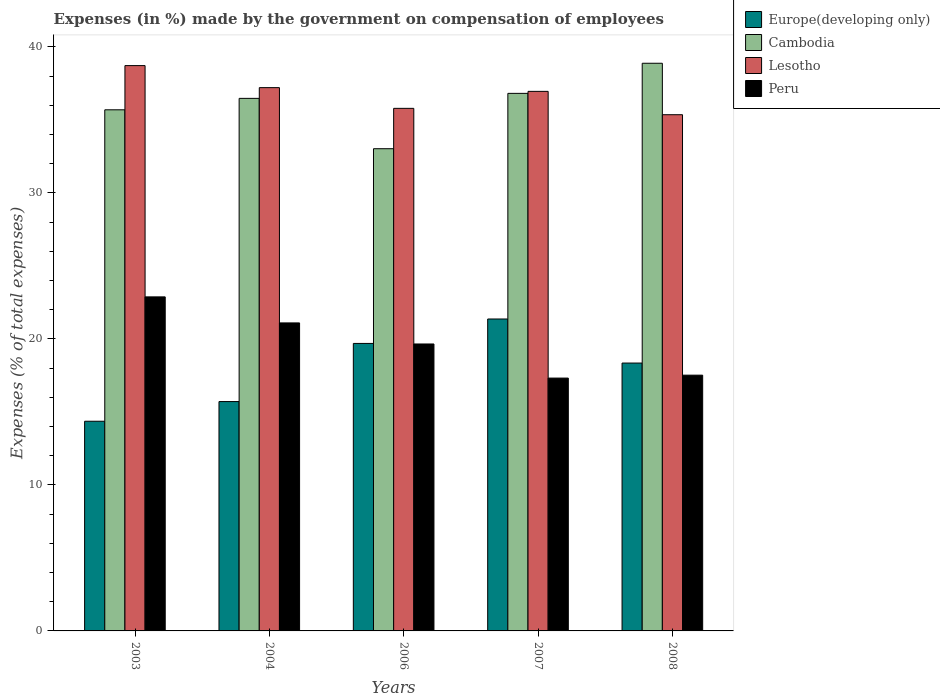How many different coloured bars are there?
Ensure brevity in your answer.  4. Are the number of bars on each tick of the X-axis equal?
Provide a short and direct response. Yes. What is the percentage of expenses made by the government on compensation of employees in Cambodia in 2003?
Make the answer very short. 35.7. Across all years, what is the maximum percentage of expenses made by the government on compensation of employees in Cambodia?
Your answer should be compact. 38.88. Across all years, what is the minimum percentage of expenses made by the government on compensation of employees in Peru?
Give a very brief answer. 17.32. In which year was the percentage of expenses made by the government on compensation of employees in Peru minimum?
Ensure brevity in your answer.  2007. What is the total percentage of expenses made by the government on compensation of employees in Peru in the graph?
Ensure brevity in your answer.  98.47. What is the difference between the percentage of expenses made by the government on compensation of employees in Cambodia in 2004 and that in 2008?
Your answer should be compact. -2.41. What is the difference between the percentage of expenses made by the government on compensation of employees in Europe(developing only) in 2007 and the percentage of expenses made by the government on compensation of employees in Peru in 2003?
Offer a very short reply. -1.52. What is the average percentage of expenses made by the government on compensation of employees in Cambodia per year?
Ensure brevity in your answer.  36.18. In the year 2007, what is the difference between the percentage of expenses made by the government on compensation of employees in Peru and percentage of expenses made by the government on compensation of employees in Cambodia?
Ensure brevity in your answer.  -19.5. What is the ratio of the percentage of expenses made by the government on compensation of employees in Cambodia in 2003 to that in 2007?
Provide a succinct answer. 0.97. Is the percentage of expenses made by the government on compensation of employees in Cambodia in 2003 less than that in 2008?
Your response must be concise. Yes. What is the difference between the highest and the second highest percentage of expenses made by the government on compensation of employees in Lesotho?
Your answer should be compact. 1.51. What is the difference between the highest and the lowest percentage of expenses made by the government on compensation of employees in Lesotho?
Make the answer very short. 3.36. In how many years, is the percentage of expenses made by the government on compensation of employees in Europe(developing only) greater than the average percentage of expenses made by the government on compensation of employees in Europe(developing only) taken over all years?
Provide a short and direct response. 3. Is the sum of the percentage of expenses made by the government on compensation of employees in Peru in 2003 and 2004 greater than the maximum percentage of expenses made by the government on compensation of employees in Europe(developing only) across all years?
Your response must be concise. Yes. What does the 2nd bar from the left in 2008 represents?
Provide a short and direct response. Cambodia. What does the 4th bar from the right in 2006 represents?
Your response must be concise. Europe(developing only). Is it the case that in every year, the sum of the percentage of expenses made by the government on compensation of employees in Europe(developing only) and percentage of expenses made by the government on compensation of employees in Peru is greater than the percentage of expenses made by the government on compensation of employees in Cambodia?
Your response must be concise. No. How many bars are there?
Your answer should be very brief. 20. Does the graph contain any zero values?
Your response must be concise. No. Does the graph contain grids?
Keep it short and to the point. No. Where does the legend appear in the graph?
Give a very brief answer. Top right. What is the title of the graph?
Offer a very short reply. Expenses (in %) made by the government on compensation of employees. What is the label or title of the X-axis?
Your answer should be compact. Years. What is the label or title of the Y-axis?
Offer a terse response. Expenses (% of total expenses). What is the Expenses (% of total expenses) of Europe(developing only) in 2003?
Offer a very short reply. 14.36. What is the Expenses (% of total expenses) in Cambodia in 2003?
Offer a terse response. 35.7. What is the Expenses (% of total expenses) of Lesotho in 2003?
Give a very brief answer. 38.72. What is the Expenses (% of total expenses) of Peru in 2003?
Offer a very short reply. 22.88. What is the Expenses (% of total expenses) of Europe(developing only) in 2004?
Your answer should be very brief. 15.71. What is the Expenses (% of total expenses) in Cambodia in 2004?
Provide a succinct answer. 36.48. What is the Expenses (% of total expenses) in Lesotho in 2004?
Offer a terse response. 37.21. What is the Expenses (% of total expenses) of Peru in 2004?
Your answer should be compact. 21.1. What is the Expenses (% of total expenses) in Europe(developing only) in 2006?
Your answer should be very brief. 19.69. What is the Expenses (% of total expenses) of Cambodia in 2006?
Provide a succinct answer. 33.03. What is the Expenses (% of total expenses) in Lesotho in 2006?
Your answer should be very brief. 35.8. What is the Expenses (% of total expenses) of Peru in 2006?
Keep it short and to the point. 19.65. What is the Expenses (% of total expenses) of Europe(developing only) in 2007?
Offer a terse response. 21.37. What is the Expenses (% of total expenses) in Cambodia in 2007?
Provide a succinct answer. 36.82. What is the Expenses (% of total expenses) of Lesotho in 2007?
Provide a short and direct response. 36.96. What is the Expenses (% of total expenses) in Peru in 2007?
Make the answer very short. 17.32. What is the Expenses (% of total expenses) of Europe(developing only) in 2008?
Ensure brevity in your answer.  18.35. What is the Expenses (% of total expenses) of Cambodia in 2008?
Your answer should be very brief. 38.88. What is the Expenses (% of total expenses) in Lesotho in 2008?
Your answer should be very brief. 35.36. What is the Expenses (% of total expenses) in Peru in 2008?
Make the answer very short. 17.52. Across all years, what is the maximum Expenses (% of total expenses) in Europe(developing only)?
Your response must be concise. 21.37. Across all years, what is the maximum Expenses (% of total expenses) in Cambodia?
Provide a short and direct response. 38.88. Across all years, what is the maximum Expenses (% of total expenses) in Lesotho?
Your response must be concise. 38.72. Across all years, what is the maximum Expenses (% of total expenses) in Peru?
Provide a short and direct response. 22.88. Across all years, what is the minimum Expenses (% of total expenses) in Europe(developing only)?
Your answer should be very brief. 14.36. Across all years, what is the minimum Expenses (% of total expenses) of Cambodia?
Keep it short and to the point. 33.03. Across all years, what is the minimum Expenses (% of total expenses) of Lesotho?
Offer a terse response. 35.36. Across all years, what is the minimum Expenses (% of total expenses) of Peru?
Make the answer very short. 17.32. What is the total Expenses (% of total expenses) of Europe(developing only) in the graph?
Make the answer very short. 89.48. What is the total Expenses (% of total expenses) of Cambodia in the graph?
Your answer should be very brief. 180.91. What is the total Expenses (% of total expenses) in Lesotho in the graph?
Give a very brief answer. 184.05. What is the total Expenses (% of total expenses) in Peru in the graph?
Give a very brief answer. 98.47. What is the difference between the Expenses (% of total expenses) of Europe(developing only) in 2003 and that in 2004?
Offer a very short reply. -1.35. What is the difference between the Expenses (% of total expenses) of Cambodia in 2003 and that in 2004?
Your answer should be compact. -0.78. What is the difference between the Expenses (% of total expenses) in Lesotho in 2003 and that in 2004?
Ensure brevity in your answer.  1.51. What is the difference between the Expenses (% of total expenses) in Peru in 2003 and that in 2004?
Make the answer very short. 1.78. What is the difference between the Expenses (% of total expenses) of Europe(developing only) in 2003 and that in 2006?
Ensure brevity in your answer.  -5.33. What is the difference between the Expenses (% of total expenses) of Cambodia in 2003 and that in 2006?
Make the answer very short. 2.67. What is the difference between the Expenses (% of total expenses) in Lesotho in 2003 and that in 2006?
Your response must be concise. 2.93. What is the difference between the Expenses (% of total expenses) in Peru in 2003 and that in 2006?
Ensure brevity in your answer.  3.23. What is the difference between the Expenses (% of total expenses) of Europe(developing only) in 2003 and that in 2007?
Give a very brief answer. -7. What is the difference between the Expenses (% of total expenses) of Cambodia in 2003 and that in 2007?
Your response must be concise. -1.13. What is the difference between the Expenses (% of total expenses) in Lesotho in 2003 and that in 2007?
Give a very brief answer. 1.76. What is the difference between the Expenses (% of total expenses) of Peru in 2003 and that in 2007?
Your answer should be very brief. 5.56. What is the difference between the Expenses (% of total expenses) of Europe(developing only) in 2003 and that in 2008?
Ensure brevity in your answer.  -3.99. What is the difference between the Expenses (% of total expenses) in Cambodia in 2003 and that in 2008?
Offer a very short reply. -3.19. What is the difference between the Expenses (% of total expenses) in Lesotho in 2003 and that in 2008?
Make the answer very short. 3.36. What is the difference between the Expenses (% of total expenses) of Peru in 2003 and that in 2008?
Make the answer very short. 5.36. What is the difference between the Expenses (% of total expenses) in Europe(developing only) in 2004 and that in 2006?
Offer a terse response. -3.98. What is the difference between the Expenses (% of total expenses) of Cambodia in 2004 and that in 2006?
Your answer should be compact. 3.45. What is the difference between the Expenses (% of total expenses) in Lesotho in 2004 and that in 2006?
Provide a short and direct response. 1.42. What is the difference between the Expenses (% of total expenses) in Peru in 2004 and that in 2006?
Ensure brevity in your answer.  1.44. What is the difference between the Expenses (% of total expenses) in Europe(developing only) in 2004 and that in 2007?
Make the answer very short. -5.66. What is the difference between the Expenses (% of total expenses) of Cambodia in 2004 and that in 2007?
Provide a short and direct response. -0.34. What is the difference between the Expenses (% of total expenses) in Lesotho in 2004 and that in 2007?
Ensure brevity in your answer.  0.26. What is the difference between the Expenses (% of total expenses) of Peru in 2004 and that in 2007?
Offer a very short reply. 3.78. What is the difference between the Expenses (% of total expenses) in Europe(developing only) in 2004 and that in 2008?
Offer a very short reply. -2.64. What is the difference between the Expenses (% of total expenses) in Cambodia in 2004 and that in 2008?
Provide a short and direct response. -2.41. What is the difference between the Expenses (% of total expenses) of Lesotho in 2004 and that in 2008?
Provide a short and direct response. 1.85. What is the difference between the Expenses (% of total expenses) of Peru in 2004 and that in 2008?
Your answer should be very brief. 3.58. What is the difference between the Expenses (% of total expenses) in Europe(developing only) in 2006 and that in 2007?
Your answer should be very brief. -1.67. What is the difference between the Expenses (% of total expenses) of Cambodia in 2006 and that in 2007?
Provide a short and direct response. -3.79. What is the difference between the Expenses (% of total expenses) in Lesotho in 2006 and that in 2007?
Give a very brief answer. -1.16. What is the difference between the Expenses (% of total expenses) in Peru in 2006 and that in 2007?
Offer a terse response. 2.34. What is the difference between the Expenses (% of total expenses) of Europe(developing only) in 2006 and that in 2008?
Your answer should be very brief. 1.34. What is the difference between the Expenses (% of total expenses) in Cambodia in 2006 and that in 2008?
Your response must be concise. -5.85. What is the difference between the Expenses (% of total expenses) of Lesotho in 2006 and that in 2008?
Give a very brief answer. 0.44. What is the difference between the Expenses (% of total expenses) of Peru in 2006 and that in 2008?
Provide a short and direct response. 2.14. What is the difference between the Expenses (% of total expenses) of Europe(developing only) in 2007 and that in 2008?
Keep it short and to the point. 3.02. What is the difference between the Expenses (% of total expenses) in Cambodia in 2007 and that in 2008?
Offer a terse response. -2.06. What is the difference between the Expenses (% of total expenses) of Lesotho in 2007 and that in 2008?
Offer a very short reply. 1.6. What is the difference between the Expenses (% of total expenses) of Europe(developing only) in 2003 and the Expenses (% of total expenses) of Cambodia in 2004?
Your answer should be compact. -22.12. What is the difference between the Expenses (% of total expenses) in Europe(developing only) in 2003 and the Expenses (% of total expenses) in Lesotho in 2004?
Offer a terse response. -22.85. What is the difference between the Expenses (% of total expenses) in Europe(developing only) in 2003 and the Expenses (% of total expenses) in Peru in 2004?
Give a very brief answer. -6.74. What is the difference between the Expenses (% of total expenses) of Cambodia in 2003 and the Expenses (% of total expenses) of Lesotho in 2004?
Your answer should be compact. -1.52. What is the difference between the Expenses (% of total expenses) in Cambodia in 2003 and the Expenses (% of total expenses) in Peru in 2004?
Keep it short and to the point. 14.6. What is the difference between the Expenses (% of total expenses) of Lesotho in 2003 and the Expenses (% of total expenses) of Peru in 2004?
Provide a short and direct response. 17.63. What is the difference between the Expenses (% of total expenses) in Europe(developing only) in 2003 and the Expenses (% of total expenses) in Cambodia in 2006?
Keep it short and to the point. -18.67. What is the difference between the Expenses (% of total expenses) of Europe(developing only) in 2003 and the Expenses (% of total expenses) of Lesotho in 2006?
Provide a succinct answer. -21.43. What is the difference between the Expenses (% of total expenses) in Europe(developing only) in 2003 and the Expenses (% of total expenses) in Peru in 2006?
Provide a short and direct response. -5.29. What is the difference between the Expenses (% of total expenses) of Cambodia in 2003 and the Expenses (% of total expenses) of Lesotho in 2006?
Keep it short and to the point. -0.1. What is the difference between the Expenses (% of total expenses) in Cambodia in 2003 and the Expenses (% of total expenses) in Peru in 2006?
Offer a terse response. 16.04. What is the difference between the Expenses (% of total expenses) in Lesotho in 2003 and the Expenses (% of total expenses) in Peru in 2006?
Keep it short and to the point. 19.07. What is the difference between the Expenses (% of total expenses) in Europe(developing only) in 2003 and the Expenses (% of total expenses) in Cambodia in 2007?
Offer a very short reply. -22.46. What is the difference between the Expenses (% of total expenses) in Europe(developing only) in 2003 and the Expenses (% of total expenses) in Lesotho in 2007?
Your answer should be compact. -22.6. What is the difference between the Expenses (% of total expenses) of Europe(developing only) in 2003 and the Expenses (% of total expenses) of Peru in 2007?
Offer a very short reply. -2.96. What is the difference between the Expenses (% of total expenses) in Cambodia in 2003 and the Expenses (% of total expenses) in Lesotho in 2007?
Keep it short and to the point. -1.26. What is the difference between the Expenses (% of total expenses) of Cambodia in 2003 and the Expenses (% of total expenses) of Peru in 2007?
Your answer should be very brief. 18.38. What is the difference between the Expenses (% of total expenses) of Lesotho in 2003 and the Expenses (% of total expenses) of Peru in 2007?
Make the answer very short. 21.4. What is the difference between the Expenses (% of total expenses) of Europe(developing only) in 2003 and the Expenses (% of total expenses) of Cambodia in 2008?
Your response must be concise. -24.52. What is the difference between the Expenses (% of total expenses) in Europe(developing only) in 2003 and the Expenses (% of total expenses) in Lesotho in 2008?
Offer a very short reply. -21. What is the difference between the Expenses (% of total expenses) of Europe(developing only) in 2003 and the Expenses (% of total expenses) of Peru in 2008?
Ensure brevity in your answer.  -3.16. What is the difference between the Expenses (% of total expenses) of Cambodia in 2003 and the Expenses (% of total expenses) of Lesotho in 2008?
Offer a terse response. 0.34. What is the difference between the Expenses (% of total expenses) in Cambodia in 2003 and the Expenses (% of total expenses) in Peru in 2008?
Make the answer very short. 18.18. What is the difference between the Expenses (% of total expenses) of Lesotho in 2003 and the Expenses (% of total expenses) of Peru in 2008?
Give a very brief answer. 21.2. What is the difference between the Expenses (% of total expenses) of Europe(developing only) in 2004 and the Expenses (% of total expenses) of Cambodia in 2006?
Ensure brevity in your answer.  -17.32. What is the difference between the Expenses (% of total expenses) of Europe(developing only) in 2004 and the Expenses (% of total expenses) of Lesotho in 2006?
Your answer should be compact. -20.09. What is the difference between the Expenses (% of total expenses) of Europe(developing only) in 2004 and the Expenses (% of total expenses) of Peru in 2006?
Provide a succinct answer. -3.95. What is the difference between the Expenses (% of total expenses) in Cambodia in 2004 and the Expenses (% of total expenses) in Lesotho in 2006?
Keep it short and to the point. 0.68. What is the difference between the Expenses (% of total expenses) in Cambodia in 2004 and the Expenses (% of total expenses) in Peru in 2006?
Provide a succinct answer. 16.82. What is the difference between the Expenses (% of total expenses) in Lesotho in 2004 and the Expenses (% of total expenses) in Peru in 2006?
Give a very brief answer. 17.56. What is the difference between the Expenses (% of total expenses) in Europe(developing only) in 2004 and the Expenses (% of total expenses) in Cambodia in 2007?
Your answer should be very brief. -21.11. What is the difference between the Expenses (% of total expenses) in Europe(developing only) in 2004 and the Expenses (% of total expenses) in Lesotho in 2007?
Offer a terse response. -21.25. What is the difference between the Expenses (% of total expenses) in Europe(developing only) in 2004 and the Expenses (% of total expenses) in Peru in 2007?
Ensure brevity in your answer.  -1.61. What is the difference between the Expenses (% of total expenses) of Cambodia in 2004 and the Expenses (% of total expenses) of Lesotho in 2007?
Your answer should be very brief. -0.48. What is the difference between the Expenses (% of total expenses) of Cambodia in 2004 and the Expenses (% of total expenses) of Peru in 2007?
Provide a short and direct response. 19.16. What is the difference between the Expenses (% of total expenses) of Lesotho in 2004 and the Expenses (% of total expenses) of Peru in 2007?
Provide a succinct answer. 19.89. What is the difference between the Expenses (% of total expenses) in Europe(developing only) in 2004 and the Expenses (% of total expenses) in Cambodia in 2008?
Provide a succinct answer. -23.17. What is the difference between the Expenses (% of total expenses) of Europe(developing only) in 2004 and the Expenses (% of total expenses) of Lesotho in 2008?
Provide a short and direct response. -19.65. What is the difference between the Expenses (% of total expenses) of Europe(developing only) in 2004 and the Expenses (% of total expenses) of Peru in 2008?
Your answer should be very brief. -1.81. What is the difference between the Expenses (% of total expenses) in Cambodia in 2004 and the Expenses (% of total expenses) in Lesotho in 2008?
Provide a succinct answer. 1.12. What is the difference between the Expenses (% of total expenses) of Cambodia in 2004 and the Expenses (% of total expenses) of Peru in 2008?
Provide a short and direct response. 18.96. What is the difference between the Expenses (% of total expenses) of Lesotho in 2004 and the Expenses (% of total expenses) of Peru in 2008?
Make the answer very short. 19.69. What is the difference between the Expenses (% of total expenses) of Europe(developing only) in 2006 and the Expenses (% of total expenses) of Cambodia in 2007?
Your answer should be very brief. -17.13. What is the difference between the Expenses (% of total expenses) of Europe(developing only) in 2006 and the Expenses (% of total expenses) of Lesotho in 2007?
Offer a very short reply. -17.27. What is the difference between the Expenses (% of total expenses) in Europe(developing only) in 2006 and the Expenses (% of total expenses) in Peru in 2007?
Offer a terse response. 2.37. What is the difference between the Expenses (% of total expenses) in Cambodia in 2006 and the Expenses (% of total expenses) in Lesotho in 2007?
Ensure brevity in your answer.  -3.93. What is the difference between the Expenses (% of total expenses) of Cambodia in 2006 and the Expenses (% of total expenses) of Peru in 2007?
Provide a short and direct response. 15.71. What is the difference between the Expenses (% of total expenses) in Lesotho in 2006 and the Expenses (% of total expenses) in Peru in 2007?
Give a very brief answer. 18.48. What is the difference between the Expenses (% of total expenses) of Europe(developing only) in 2006 and the Expenses (% of total expenses) of Cambodia in 2008?
Provide a succinct answer. -19.19. What is the difference between the Expenses (% of total expenses) of Europe(developing only) in 2006 and the Expenses (% of total expenses) of Lesotho in 2008?
Ensure brevity in your answer.  -15.67. What is the difference between the Expenses (% of total expenses) of Europe(developing only) in 2006 and the Expenses (% of total expenses) of Peru in 2008?
Provide a succinct answer. 2.17. What is the difference between the Expenses (% of total expenses) of Cambodia in 2006 and the Expenses (% of total expenses) of Lesotho in 2008?
Provide a short and direct response. -2.33. What is the difference between the Expenses (% of total expenses) in Cambodia in 2006 and the Expenses (% of total expenses) in Peru in 2008?
Ensure brevity in your answer.  15.51. What is the difference between the Expenses (% of total expenses) in Lesotho in 2006 and the Expenses (% of total expenses) in Peru in 2008?
Your response must be concise. 18.28. What is the difference between the Expenses (% of total expenses) in Europe(developing only) in 2007 and the Expenses (% of total expenses) in Cambodia in 2008?
Your answer should be compact. -17.52. What is the difference between the Expenses (% of total expenses) of Europe(developing only) in 2007 and the Expenses (% of total expenses) of Lesotho in 2008?
Keep it short and to the point. -13.99. What is the difference between the Expenses (% of total expenses) in Europe(developing only) in 2007 and the Expenses (% of total expenses) in Peru in 2008?
Ensure brevity in your answer.  3.85. What is the difference between the Expenses (% of total expenses) in Cambodia in 2007 and the Expenses (% of total expenses) in Lesotho in 2008?
Provide a short and direct response. 1.46. What is the difference between the Expenses (% of total expenses) of Cambodia in 2007 and the Expenses (% of total expenses) of Peru in 2008?
Give a very brief answer. 19.3. What is the difference between the Expenses (% of total expenses) of Lesotho in 2007 and the Expenses (% of total expenses) of Peru in 2008?
Your response must be concise. 19.44. What is the average Expenses (% of total expenses) in Europe(developing only) per year?
Make the answer very short. 17.9. What is the average Expenses (% of total expenses) of Cambodia per year?
Give a very brief answer. 36.18. What is the average Expenses (% of total expenses) in Lesotho per year?
Offer a terse response. 36.81. What is the average Expenses (% of total expenses) of Peru per year?
Provide a short and direct response. 19.69. In the year 2003, what is the difference between the Expenses (% of total expenses) in Europe(developing only) and Expenses (% of total expenses) in Cambodia?
Offer a terse response. -21.33. In the year 2003, what is the difference between the Expenses (% of total expenses) of Europe(developing only) and Expenses (% of total expenses) of Lesotho?
Your answer should be very brief. -24.36. In the year 2003, what is the difference between the Expenses (% of total expenses) of Europe(developing only) and Expenses (% of total expenses) of Peru?
Keep it short and to the point. -8.52. In the year 2003, what is the difference between the Expenses (% of total expenses) of Cambodia and Expenses (% of total expenses) of Lesotho?
Your answer should be compact. -3.03. In the year 2003, what is the difference between the Expenses (% of total expenses) in Cambodia and Expenses (% of total expenses) in Peru?
Make the answer very short. 12.81. In the year 2003, what is the difference between the Expenses (% of total expenses) in Lesotho and Expenses (% of total expenses) in Peru?
Offer a terse response. 15.84. In the year 2004, what is the difference between the Expenses (% of total expenses) in Europe(developing only) and Expenses (% of total expenses) in Cambodia?
Your answer should be compact. -20.77. In the year 2004, what is the difference between the Expenses (% of total expenses) of Europe(developing only) and Expenses (% of total expenses) of Lesotho?
Your answer should be very brief. -21.5. In the year 2004, what is the difference between the Expenses (% of total expenses) of Europe(developing only) and Expenses (% of total expenses) of Peru?
Your response must be concise. -5.39. In the year 2004, what is the difference between the Expenses (% of total expenses) of Cambodia and Expenses (% of total expenses) of Lesotho?
Offer a very short reply. -0.74. In the year 2004, what is the difference between the Expenses (% of total expenses) in Cambodia and Expenses (% of total expenses) in Peru?
Provide a short and direct response. 15.38. In the year 2004, what is the difference between the Expenses (% of total expenses) of Lesotho and Expenses (% of total expenses) of Peru?
Offer a very short reply. 16.12. In the year 2006, what is the difference between the Expenses (% of total expenses) in Europe(developing only) and Expenses (% of total expenses) in Cambodia?
Your answer should be compact. -13.34. In the year 2006, what is the difference between the Expenses (% of total expenses) in Europe(developing only) and Expenses (% of total expenses) in Lesotho?
Your answer should be compact. -16.1. In the year 2006, what is the difference between the Expenses (% of total expenses) in Europe(developing only) and Expenses (% of total expenses) in Peru?
Offer a very short reply. 0.04. In the year 2006, what is the difference between the Expenses (% of total expenses) in Cambodia and Expenses (% of total expenses) in Lesotho?
Offer a very short reply. -2.77. In the year 2006, what is the difference between the Expenses (% of total expenses) in Cambodia and Expenses (% of total expenses) in Peru?
Make the answer very short. 13.37. In the year 2006, what is the difference between the Expenses (% of total expenses) of Lesotho and Expenses (% of total expenses) of Peru?
Your answer should be very brief. 16.14. In the year 2007, what is the difference between the Expenses (% of total expenses) in Europe(developing only) and Expenses (% of total expenses) in Cambodia?
Offer a very short reply. -15.46. In the year 2007, what is the difference between the Expenses (% of total expenses) of Europe(developing only) and Expenses (% of total expenses) of Lesotho?
Provide a succinct answer. -15.59. In the year 2007, what is the difference between the Expenses (% of total expenses) of Europe(developing only) and Expenses (% of total expenses) of Peru?
Provide a short and direct response. 4.05. In the year 2007, what is the difference between the Expenses (% of total expenses) of Cambodia and Expenses (% of total expenses) of Lesotho?
Offer a very short reply. -0.14. In the year 2007, what is the difference between the Expenses (% of total expenses) in Cambodia and Expenses (% of total expenses) in Peru?
Keep it short and to the point. 19.5. In the year 2007, what is the difference between the Expenses (% of total expenses) in Lesotho and Expenses (% of total expenses) in Peru?
Offer a very short reply. 19.64. In the year 2008, what is the difference between the Expenses (% of total expenses) of Europe(developing only) and Expenses (% of total expenses) of Cambodia?
Make the answer very short. -20.54. In the year 2008, what is the difference between the Expenses (% of total expenses) in Europe(developing only) and Expenses (% of total expenses) in Lesotho?
Your response must be concise. -17.01. In the year 2008, what is the difference between the Expenses (% of total expenses) in Europe(developing only) and Expenses (% of total expenses) in Peru?
Give a very brief answer. 0.83. In the year 2008, what is the difference between the Expenses (% of total expenses) of Cambodia and Expenses (% of total expenses) of Lesotho?
Keep it short and to the point. 3.52. In the year 2008, what is the difference between the Expenses (% of total expenses) in Cambodia and Expenses (% of total expenses) in Peru?
Keep it short and to the point. 21.36. In the year 2008, what is the difference between the Expenses (% of total expenses) of Lesotho and Expenses (% of total expenses) of Peru?
Offer a very short reply. 17.84. What is the ratio of the Expenses (% of total expenses) of Europe(developing only) in 2003 to that in 2004?
Ensure brevity in your answer.  0.91. What is the ratio of the Expenses (% of total expenses) of Cambodia in 2003 to that in 2004?
Keep it short and to the point. 0.98. What is the ratio of the Expenses (% of total expenses) of Lesotho in 2003 to that in 2004?
Offer a very short reply. 1.04. What is the ratio of the Expenses (% of total expenses) of Peru in 2003 to that in 2004?
Your answer should be very brief. 1.08. What is the ratio of the Expenses (% of total expenses) in Europe(developing only) in 2003 to that in 2006?
Your response must be concise. 0.73. What is the ratio of the Expenses (% of total expenses) of Cambodia in 2003 to that in 2006?
Offer a very short reply. 1.08. What is the ratio of the Expenses (% of total expenses) of Lesotho in 2003 to that in 2006?
Provide a short and direct response. 1.08. What is the ratio of the Expenses (% of total expenses) of Peru in 2003 to that in 2006?
Offer a very short reply. 1.16. What is the ratio of the Expenses (% of total expenses) in Europe(developing only) in 2003 to that in 2007?
Ensure brevity in your answer.  0.67. What is the ratio of the Expenses (% of total expenses) in Cambodia in 2003 to that in 2007?
Offer a very short reply. 0.97. What is the ratio of the Expenses (% of total expenses) of Lesotho in 2003 to that in 2007?
Keep it short and to the point. 1.05. What is the ratio of the Expenses (% of total expenses) of Peru in 2003 to that in 2007?
Ensure brevity in your answer.  1.32. What is the ratio of the Expenses (% of total expenses) of Europe(developing only) in 2003 to that in 2008?
Ensure brevity in your answer.  0.78. What is the ratio of the Expenses (% of total expenses) in Cambodia in 2003 to that in 2008?
Make the answer very short. 0.92. What is the ratio of the Expenses (% of total expenses) in Lesotho in 2003 to that in 2008?
Your response must be concise. 1.1. What is the ratio of the Expenses (% of total expenses) of Peru in 2003 to that in 2008?
Make the answer very short. 1.31. What is the ratio of the Expenses (% of total expenses) of Europe(developing only) in 2004 to that in 2006?
Provide a short and direct response. 0.8. What is the ratio of the Expenses (% of total expenses) of Cambodia in 2004 to that in 2006?
Give a very brief answer. 1.1. What is the ratio of the Expenses (% of total expenses) in Lesotho in 2004 to that in 2006?
Provide a short and direct response. 1.04. What is the ratio of the Expenses (% of total expenses) in Peru in 2004 to that in 2006?
Your answer should be compact. 1.07. What is the ratio of the Expenses (% of total expenses) of Europe(developing only) in 2004 to that in 2007?
Offer a terse response. 0.74. What is the ratio of the Expenses (% of total expenses) of Lesotho in 2004 to that in 2007?
Offer a very short reply. 1.01. What is the ratio of the Expenses (% of total expenses) of Peru in 2004 to that in 2007?
Offer a terse response. 1.22. What is the ratio of the Expenses (% of total expenses) of Europe(developing only) in 2004 to that in 2008?
Keep it short and to the point. 0.86. What is the ratio of the Expenses (% of total expenses) of Cambodia in 2004 to that in 2008?
Offer a very short reply. 0.94. What is the ratio of the Expenses (% of total expenses) in Lesotho in 2004 to that in 2008?
Your answer should be compact. 1.05. What is the ratio of the Expenses (% of total expenses) in Peru in 2004 to that in 2008?
Offer a terse response. 1.2. What is the ratio of the Expenses (% of total expenses) of Europe(developing only) in 2006 to that in 2007?
Ensure brevity in your answer.  0.92. What is the ratio of the Expenses (% of total expenses) in Cambodia in 2006 to that in 2007?
Your answer should be compact. 0.9. What is the ratio of the Expenses (% of total expenses) of Lesotho in 2006 to that in 2007?
Keep it short and to the point. 0.97. What is the ratio of the Expenses (% of total expenses) in Peru in 2006 to that in 2007?
Provide a short and direct response. 1.13. What is the ratio of the Expenses (% of total expenses) of Europe(developing only) in 2006 to that in 2008?
Your answer should be very brief. 1.07. What is the ratio of the Expenses (% of total expenses) in Cambodia in 2006 to that in 2008?
Your answer should be compact. 0.85. What is the ratio of the Expenses (% of total expenses) of Lesotho in 2006 to that in 2008?
Offer a terse response. 1.01. What is the ratio of the Expenses (% of total expenses) of Peru in 2006 to that in 2008?
Provide a short and direct response. 1.12. What is the ratio of the Expenses (% of total expenses) in Europe(developing only) in 2007 to that in 2008?
Offer a very short reply. 1.16. What is the ratio of the Expenses (% of total expenses) in Cambodia in 2007 to that in 2008?
Your response must be concise. 0.95. What is the ratio of the Expenses (% of total expenses) in Lesotho in 2007 to that in 2008?
Your answer should be compact. 1.05. What is the ratio of the Expenses (% of total expenses) of Peru in 2007 to that in 2008?
Your response must be concise. 0.99. What is the difference between the highest and the second highest Expenses (% of total expenses) of Europe(developing only)?
Make the answer very short. 1.67. What is the difference between the highest and the second highest Expenses (% of total expenses) of Cambodia?
Your answer should be very brief. 2.06. What is the difference between the highest and the second highest Expenses (% of total expenses) in Lesotho?
Your response must be concise. 1.51. What is the difference between the highest and the second highest Expenses (% of total expenses) of Peru?
Give a very brief answer. 1.78. What is the difference between the highest and the lowest Expenses (% of total expenses) of Europe(developing only)?
Offer a terse response. 7. What is the difference between the highest and the lowest Expenses (% of total expenses) of Cambodia?
Provide a short and direct response. 5.85. What is the difference between the highest and the lowest Expenses (% of total expenses) in Lesotho?
Ensure brevity in your answer.  3.36. What is the difference between the highest and the lowest Expenses (% of total expenses) of Peru?
Your answer should be very brief. 5.56. 